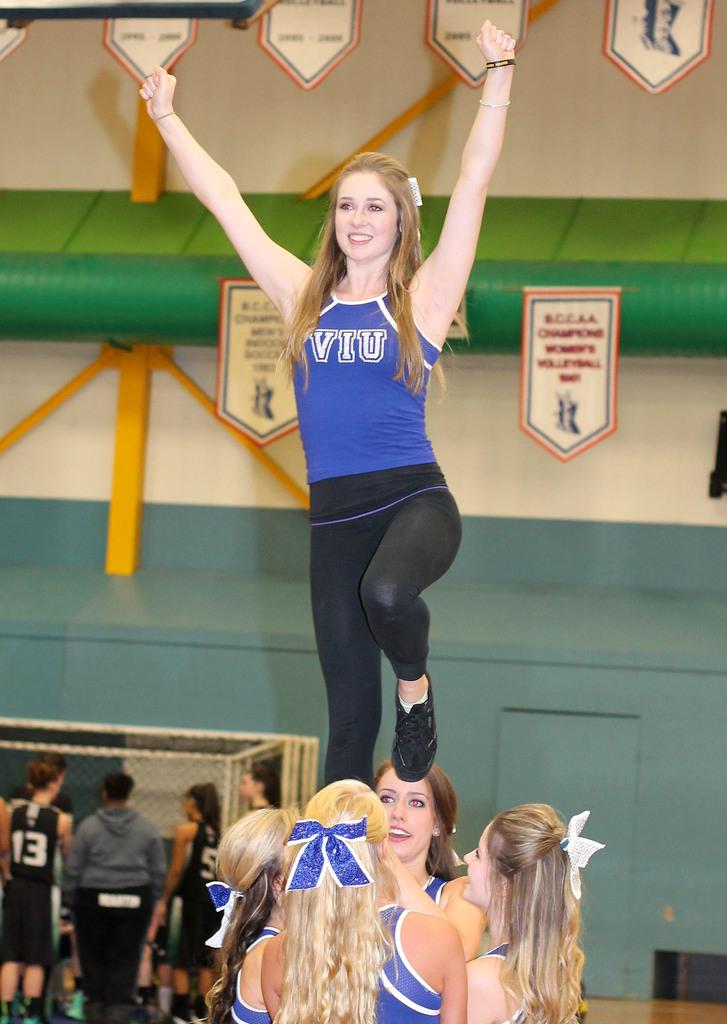What school does this girl cheer for?
Offer a terse response. Viu. What is the number on the jersey in the background?
Your response must be concise. 13. 